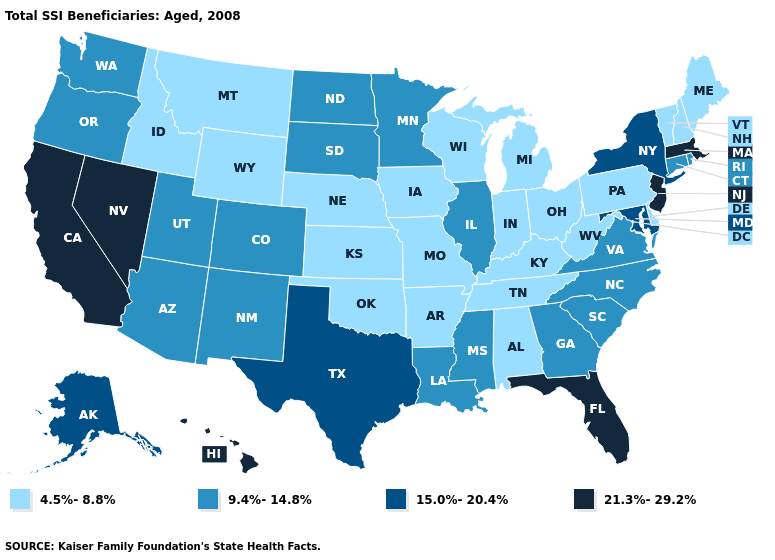Does California have the lowest value in the West?
Short answer required. No. Does New Hampshire have a lower value than Oklahoma?
Keep it brief. No. Name the states that have a value in the range 4.5%-8.8%?
Quick response, please. Alabama, Arkansas, Delaware, Idaho, Indiana, Iowa, Kansas, Kentucky, Maine, Michigan, Missouri, Montana, Nebraska, New Hampshire, Ohio, Oklahoma, Pennsylvania, Tennessee, Vermont, West Virginia, Wisconsin, Wyoming. Does Iowa have the same value as Georgia?
Concise answer only. No. What is the value of Montana?
Concise answer only. 4.5%-8.8%. What is the value of New Mexico?
Answer briefly. 9.4%-14.8%. Name the states that have a value in the range 15.0%-20.4%?
Write a very short answer. Alaska, Maryland, New York, Texas. Among the states that border New Hampshire , which have the lowest value?
Keep it brief. Maine, Vermont. What is the value of Missouri?
Answer briefly. 4.5%-8.8%. What is the value of Nevada?
Give a very brief answer. 21.3%-29.2%. What is the highest value in the West ?
Give a very brief answer. 21.3%-29.2%. Which states have the lowest value in the USA?
Short answer required. Alabama, Arkansas, Delaware, Idaho, Indiana, Iowa, Kansas, Kentucky, Maine, Michigan, Missouri, Montana, Nebraska, New Hampshire, Ohio, Oklahoma, Pennsylvania, Tennessee, Vermont, West Virginia, Wisconsin, Wyoming. Which states have the lowest value in the West?
Answer briefly. Idaho, Montana, Wyoming. Name the states that have a value in the range 4.5%-8.8%?
Answer briefly. Alabama, Arkansas, Delaware, Idaho, Indiana, Iowa, Kansas, Kentucky, Maine, Michigan, Missouri, Montana, Nebraska, New Hampshire, Ohio, Oklahoma, Pennsylvania, Tennessee, Vermont, West Virginia, Wisconsin, Wyoming. What is the value of Iowa?
Be succinct. 4.5%-8.8%. 